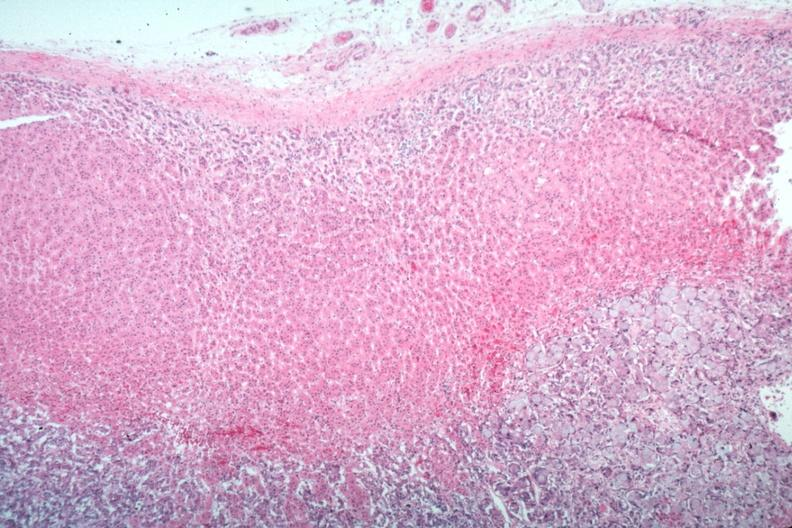what does this image show?
Answer the question using a single word or phrase. Primary in stomach 